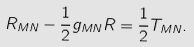Convert formula to latex. <formula><loc_0><loc_0><loc_500><loc_500>R _ { M N } - \frac { 1 } { 2 } g _ { M N } R = \frac { 1 } { 2 } T _ { M N } .</formula> 